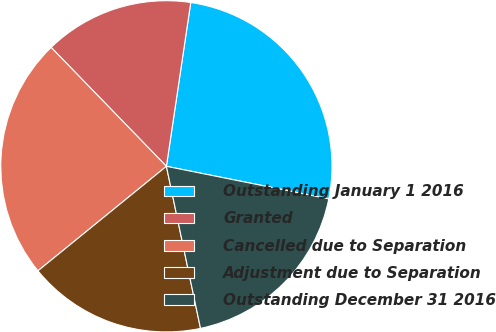Convert chart to OTSL. <chart><loc_0><loc_0><loc_500><loc_500><pie_chart><fcel>Outstanding January 1 2016<fcel>Granted<fcel>Cancelled due to Separation<fcel>Adjustment due to Separation<fcel>Outstanding December 31 2016<nl><fcel>25.8%<fcel>14.6%<fcel>23.62%<fcel>17.43%<fcel>18.55%<nl></chart> 